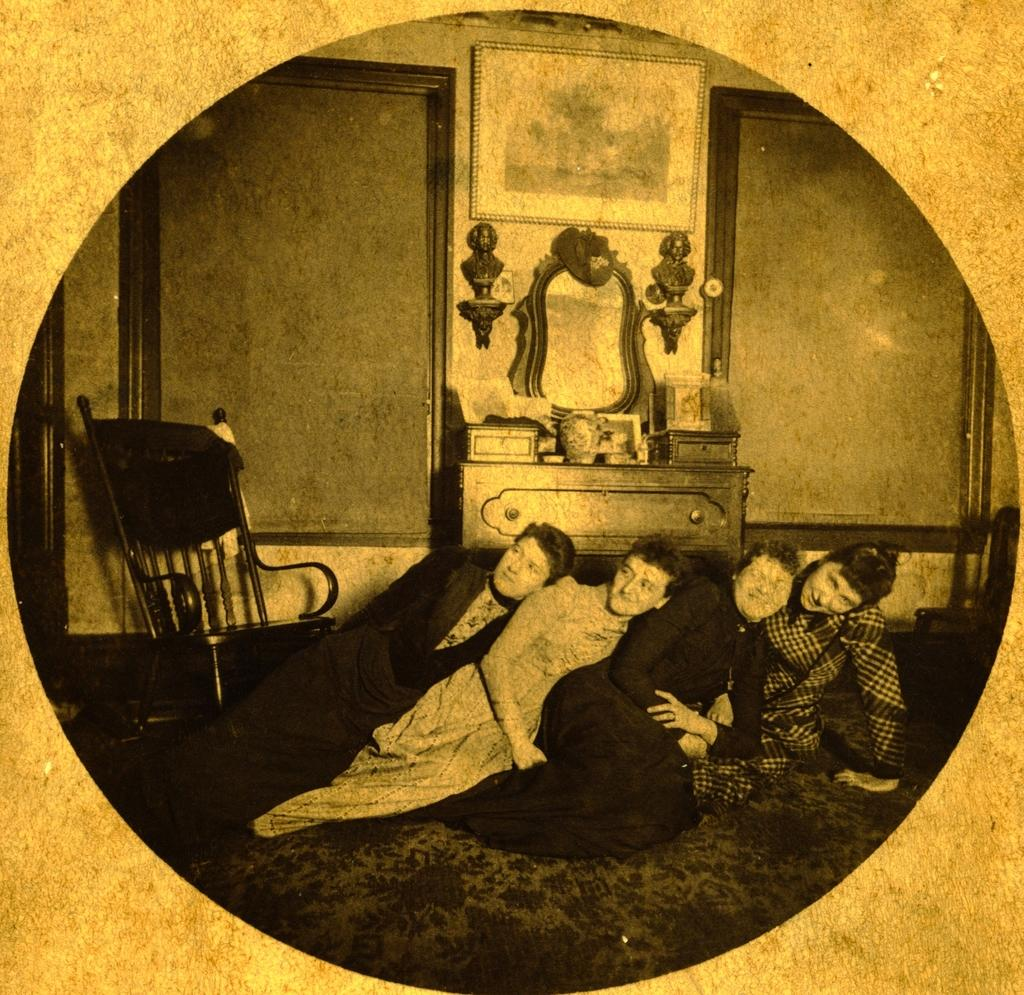What is the color scheme of the image? The image is black and white. How many people are sitting on the floor in the image? There are four people sitting on the floor in the image. Can you describe any furniture in the image? There is a chair on the left side of the image. What type of creature is learning to play the piano in the image? There is no creature or piano present in the image; it features four people sitting on the floor and a chair on the left side. 